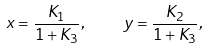<formula> <loc_0><loc_0><loc_500><loc_500>x = \frac { K _ { 1 } } { 1 + K _ { 3 } } , \quad y = \frac { K _ { 2 } } { 1 + K _ { 3 } } ,</formula> 